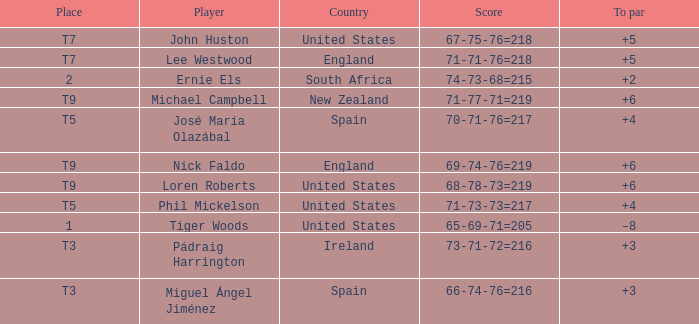Write the full table. {'header': ['Place', 'Player', 'Country', 'Score', 'To par'], 'rows': [['T7', 'John Huston', 'United States', '67-75-76=218', '+5'], ['T7', 'Lee Westwood', 'England', '71-71-76=218', '+5'], ['2', 'Ernie Els', 'South Africa', '74-73-68=215', '+2'], ['T9', 'Michael Campbell', 'New Zealand', '71-77-71=219', '+6'], ['T5', 'José María Olazábal', 'Spain', '70-71-76=217', '+4'], ['T9', 'Nick Faldo', 'England', '69-74-76=219', '+6'], ['T9', 'Loren Roberts', 'United States', '68-78-73=219', '+6'], ['T5', 'Phil Mickelson', 'United States', '71-73-73=217', '+4'], ['1', 'Tiger Woods', 'United States', '65-69-71=205', '–8'], ['T3', 'Pádraig Harrington', 'Ireland', '73-71-72=216', '+3'], ['T3', 'Miguel Ángel Jiménez', 'Spain', '66-74-76=216', '+3']]} What is Player, when Score is "66-74-76=216"? Miguel Ángel Jiménez. 